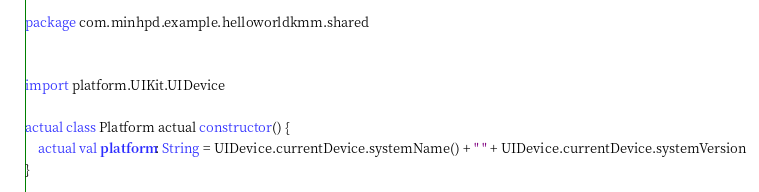Convert code to text. <code><loc_0><loc_0><loc_500><loc_500><_Kotlin_>package com.minhpd.example.helloworldkmm.shared


import platform.UIKit.UIDevice

actual class Platform actual constructor() {
    actual val platform: String = UIDevice.currentDevice.systemName() + " " + UIDevice.currentDevice.systemVersion
}</code> 